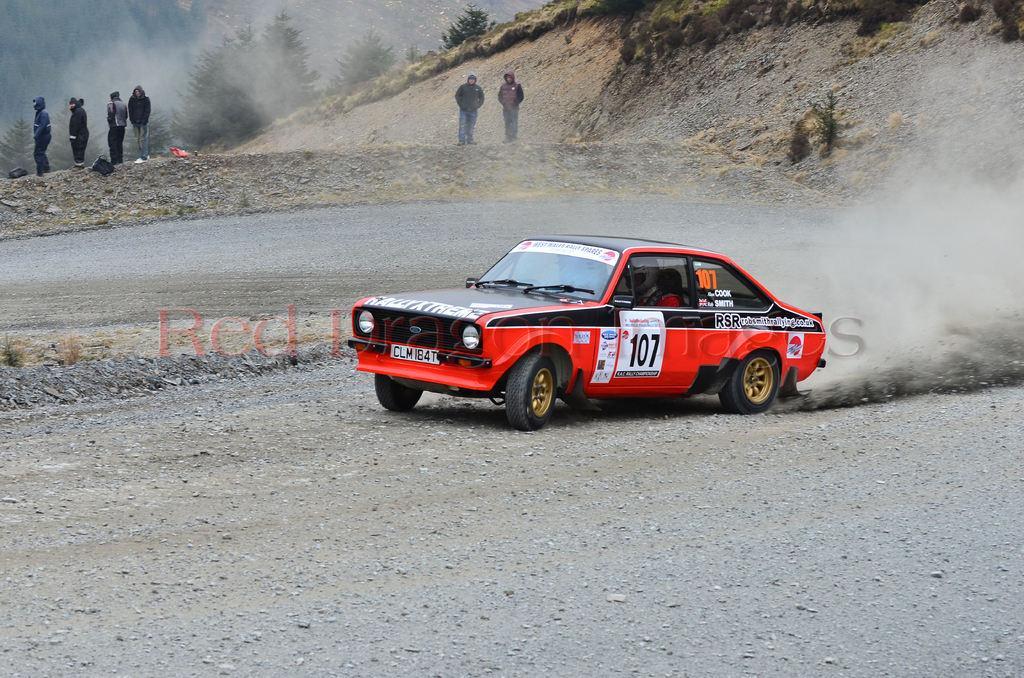Could you give a brief overview of what you see in this image? In this image in the center there is one car and one person is sitting in a car, in the background there are some people who are standing. At the bottom there is a road, and in the background there are some trees and sands and some mountains. 